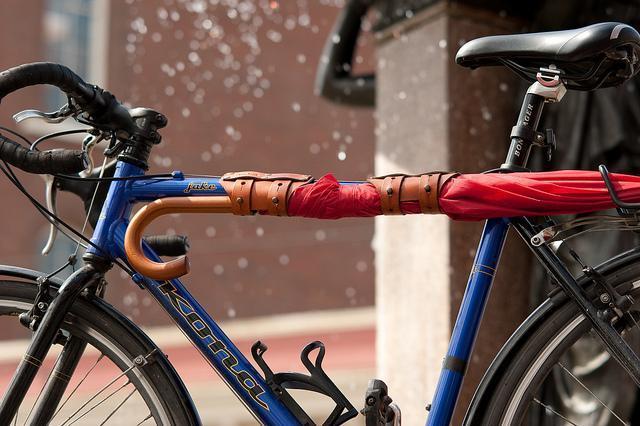How many bicycles are there?
Give a very brief answer. 1. 